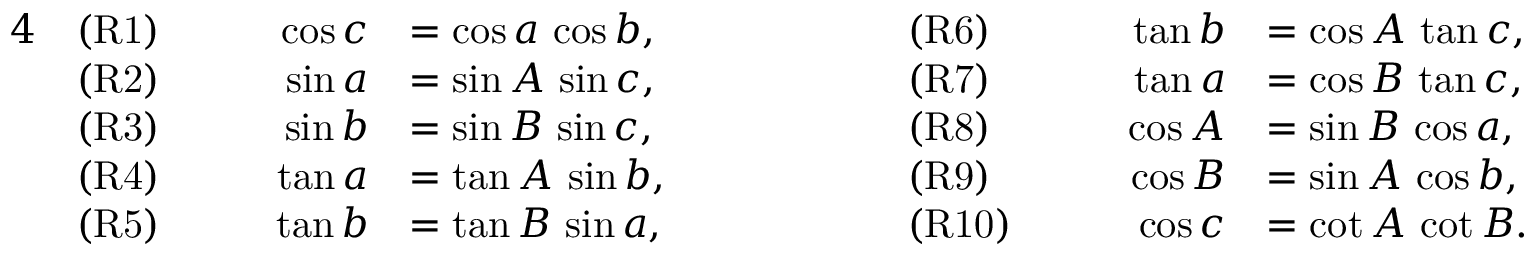<formula> <loc_0><loc_0><loc_500><loc_500>{ \begin{array} { r l r l r l r l } { 4 } & { ( R 1 ) } & { \quad \cos c } & { = \cos a \, \cos b , } & { \quad } & { ( R 6 ) } & { \quad \tan b } & { = \cos A \, \tan c , } \\ & { ( R 2 ) } & { \sin a } & { = \sin A \, \sin c , } & & { ( R 7 ) } & { \tan a } & { = \cos B \, \tan c , } \\ & { ( R 3 ) } & { \sin b } & { = \sin B \, \sin c , } & & { ( R 8 ) } & { \cos A } & { = \sin B \, \cos a , } \\ & { ( R 4 ) } & { \tan a } & { = \tan A \, \sin b , } & & { ( R 9 ) } & { \cos B } & { = \sin A \, \cos b , } \\ & { ( R 5 ) } & { \tan b } & { = \tan B \, \sin a , } & & { ( R 1 0 ) } & { \cos c } & { = \cot A \, \cot B . } \end{array} }</formula> 